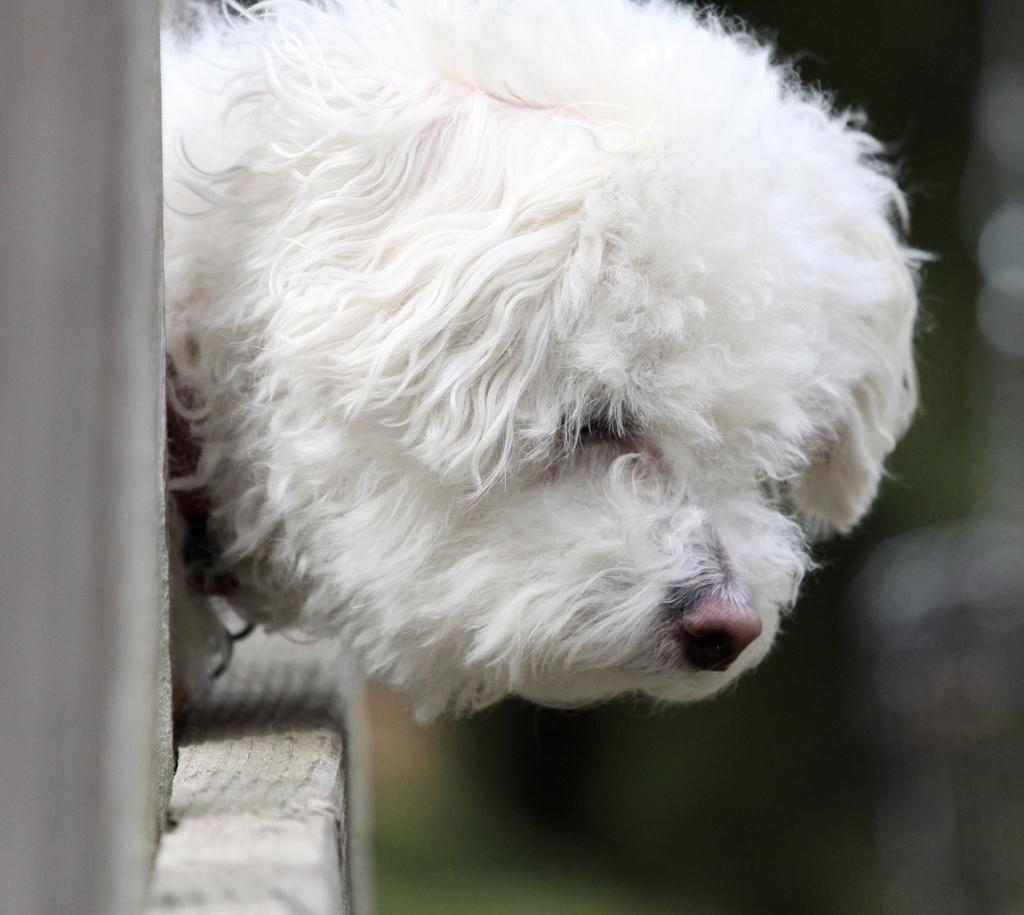What type of animal is in the image? There is a dog in the image. What can be seen in the background of the image? There is a wall in the image. Where is the crown placed on the dog in the image? There is no crown present in the image; it only features a dog and a wall. 